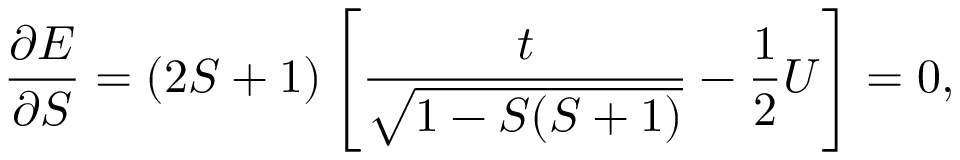Convert formula to latex. <formula><loc_0><loc_0><loc_500><loc_500>\frac { \partial E } { \partial S } = ( 2 S + 1 ) \left [ \frac { t } { \sqrt { 1 - S ( S + 1 ) } } - \frac { 1 } { 2 } U \right ] = 0 ,</formula> 